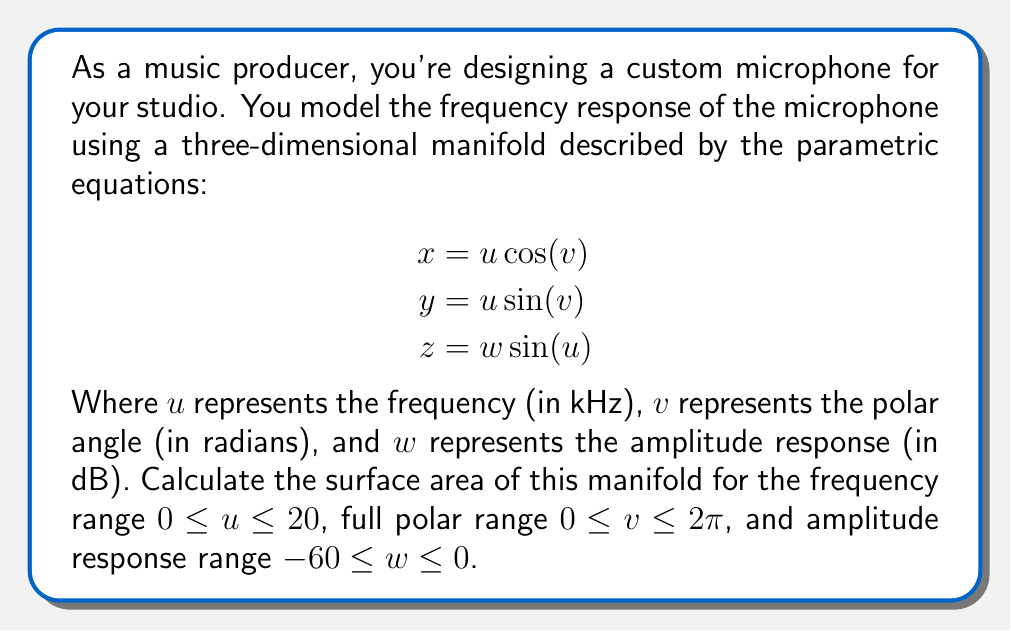Could you help me with this problem? To calculate the surface area of the three-dimensional manifold, we need to use the surface integral formula:

$$\text{Surface Area} = \int\int_S \sqrt{EG - F^2} \, dudv$$

Where $E$, $F$, and $G$ are the coefficients of the first fundamental form.

1) First, we need to calculate the partial derivatives:

   $$\frac{\partial x}{\partial u} = \cos(v), \frac{\partial x}{\partial v} = -u\sin(v)$$
   $$\frac{\partial y}{\partial u} = \sin(v), \frac{\partial y}{\partial v} = u\cos(v)$$
   $$\frac{\partial z}{\partial u} = w\cos(u), \frac{\partial z}{\partial v} = 0$$

2) Now we can calculate $E$, $F$, and $G$:

   $$E = (\frac{\partial x}{\partial u})^2 + (\frac{\partial y}{\partial u})^2 + (\frac{\partial z}{\partial u})^2 = \cos^2(v) + \sin^2(v) + w^2\cos^2(u) = 1 + w^2\cos^2(u)$$

   $$F = \frac{\partial x}{\partial u}\frac{\partial x}{\partial v} + \frac{\partial y}{\partial u}\frac{\partial y}{\partial v} + \frac{\partial z}{\partial u}\frac{\partial z}{\partial v} = -u\sin(v)\cos(v) + u\sin(v)\cos(v) + 0 = 0$$

   $$G = (\frac{\partial x}{\partial v})^2 + (\frac{\partial y}{\partial v})^2 + (\frac{\partial z}{\partial v})^2 = u^2\sin^2(v) + u^2\cos^2(v) + 0 = u^2$$

3) Substituting these into our surface area formula:

   $$\text{Surface Area} = \int_0^{20}\int_0^{2\pi}\int_{-60}^0 \sqrt{(1 + w^2\cos^2(u))u^2 - 0^2} \, dwdvdu$$

4) Simplifying:

   $$\text{Surface Area} = \int_0^{20}\int_0^{2\pi}\int_{-60}^0 u\sqrt{1 + w^2\cos^2(u)} \, dwdvdu$$

5) This triple integral is quite complex and doesn't have a straightforward analytical solution. In practice, we would use numerical integration methods to approximate the result.
Answer: The surface area of the microphone's frequency response manifold is given by the triple integral:

$$\text{Surface Area} = \int_0^{20}\int_0^{2\pi}\int_{-60}^0 u\sqrt{1 + w^2\cos^2(u)} \, dwdvdu$$

This integral requires numerical methods for accurate evaluation. 